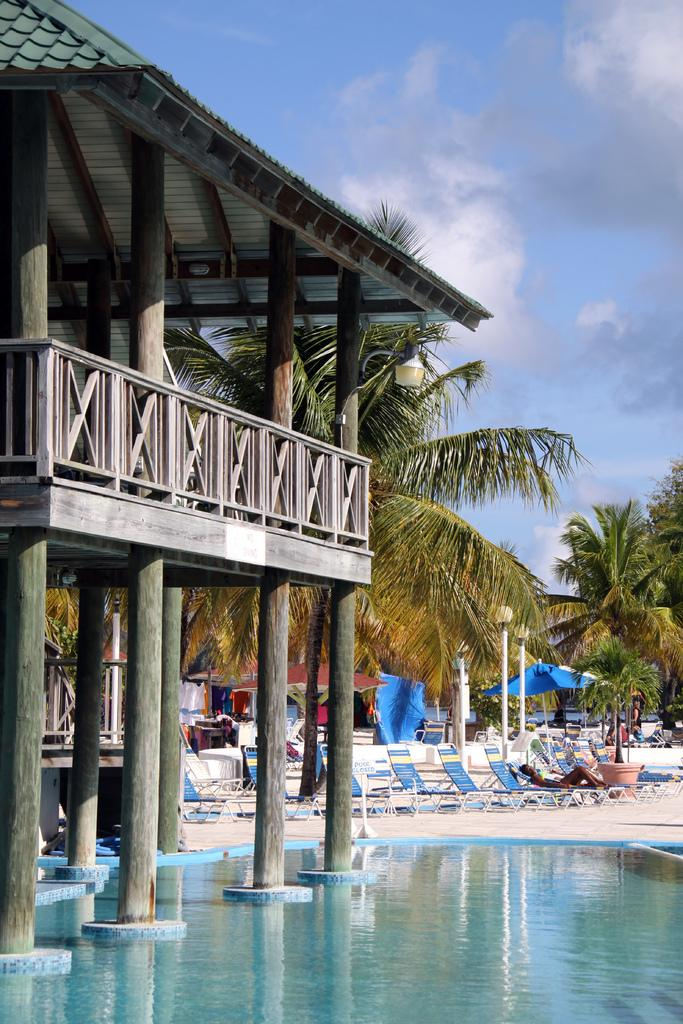What is the main feature in the image? There is a pool in the image. What structure can be seen on the left side of the image? There is a shelter on the left side of the image. What type of furniture is visible in the background of the image? Lounge chairs are visible in the background of the image. What type of vegetation is present in the background of the image? There are trees in the background of the image. What are the poles used for in the image? The poles are present in the background of the image, but their purpose is not specified. What can be seen in the sky in the image? The sky is visible in the background of the image. How many women are present in the image? There is no information about women in the image, as it primarily features a pool, shelter, and other objects. What type of pets can be seen playing in the pool? There are no pets visible in the image; it primarily features a pool, shelter, and other objects. 